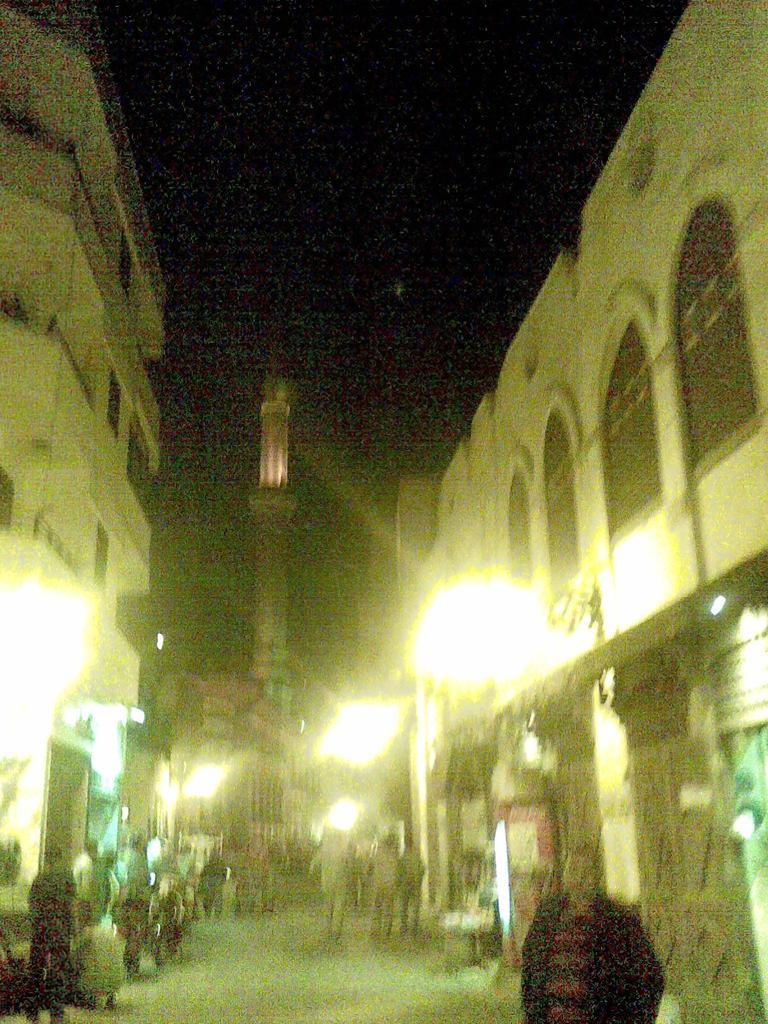How many people are in the image? There is a group of people standing in the image. What else can be seen in the image besides the people? There are buildings and lights visible in the image. What is visible in the background of the image? The sky is visible in the background of the image. How much money is being exchanged between the people in the image? There is no indication of money being exchanged in the image. Who is the creator of the buildings in the image? The creator of the buildings is not mentioned or visible in the image. 